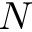<formula> <loc_0><loc_0><loc_500><loc_500>N</formula> 